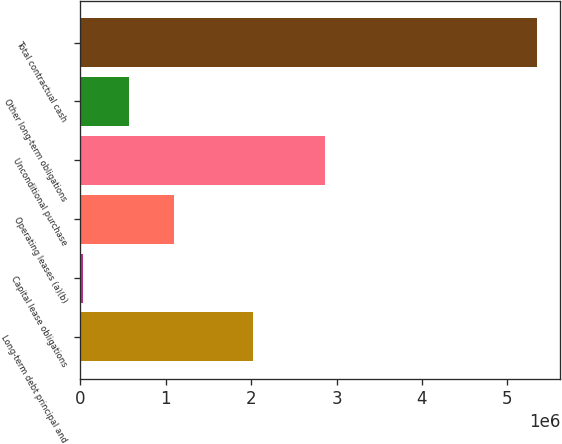Convert chart. <chart><loc_0><loc_0><loc_500><loc_500><bar_chart><fcel>Long-term debt principal and<fcel>Capital lease obligations<fcel>Operating leases (a)(b)<fcel>Unconditional purchase<fcel>Other long-term obligations<fcel>Total contractual cash<nl><fcel>2.02682e+06<fcel>36100<fcel>1.0988e+06<fcel>2.86777e+06<fcel>567452<fcel>5.34962e+06<nl></chart> 